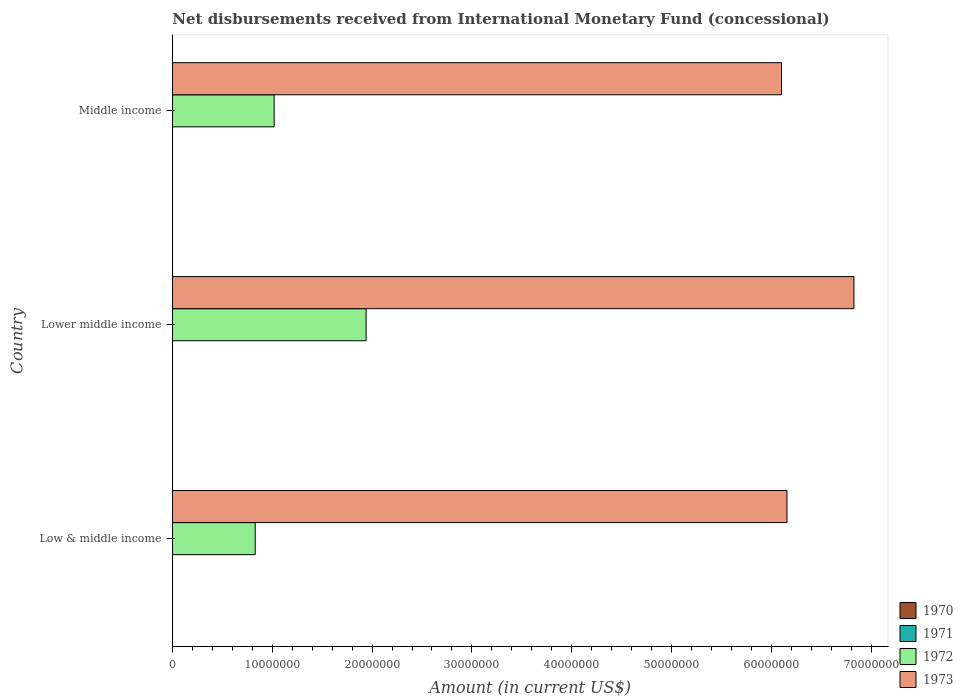How many groups of bars are there?
Provide a succinct answer. 3. Are the number of bars per tick equal to the number of legend labels?
Your answer should be very brief. No. How many bars are there on the 3rd tick from the bottom?
Offer a terse response. 2. What is the label of the 3rd group of bars from the top?
Give a very brief answer. Low & middle income. What is the amount of disbursements received from International Monetary Fund in 1973 in Middle income?
Offer a terse response. 6.10e+07. Across all countries, what is the maximum amount of disbursements received from International Monetary Fund in 1973?
Keep it short and to the point. 6.83e+07. Across all countries, what is the minimum amount of disbursements received from International Monetary Fund in 1973?
Ensure brevity in your answer.  6.10e+07. In which country was the amount of disbursements received from International Monetary Fund in 1973 maximum?
Your answer should be compact. Lower middle income. What is the difference between the amount of disbursements received from International Monetary Fund in 1972 in Low & middle income and that in Lower middle income?
Offer a terse response. -1.11e+07. What is the difference between the amount of disbursements received from International Monetary Fund in 1970 in Lower middle income and the amount of disbursements received from International Monetary Fund in 1972 in Low & middle income?
Offer a terse response. -8.30e+06. What is the difference between the amount of disbursements received from International Monetary Fund in 1973 and amount of disbursements received from International Monetary Fund in 1972 in Lower middle income?
Your response must be concise. 4.89e+07. What is the ratio of the amount of disbursements received from International Monetary Fund in 1973 in Lower middle income to that in Middle income?
Offer a terse response. 1.12. What is the difference between the highest and the second highest amount of disbursements received from International Monetary Fund in 1973?
Give a very brief answer. 6.70e+06. What is the difference between the highest and the lowest amount of disbursements received from International Monetary Fund in 1972?
Your answer should be very brief. 1.11e+07. Is the sum of the amount of disbursements received from International Monetary Fund in 1973 in Low & middle income and Middle income greater than the maximum amount of disbursements received from International Monetary Fund in 1970 across all countries?
Offer a terse response. Yes. Is it the case that in every country, the sum of the amount of disbursements received from International Monetary Fund in 1971 and amount of disbursements received from International Monetary Fund in 1970 is greater than the sum of amount of disbursements received from International Monetary Fund in 1973 and amount of disbursements received from International Monetary Fund in 1972?
Your answer should be very brief. No. Is it the case that in every country, the sum of the amount of disbursements received from International Monetary Fund in 1970 and amount of disbursements received from International Monetary Fund in 1971 is greater than the amount of disbursements received from International Monetary Fund in 1973?
Your answer should be compact. No. How many bars are there?
Make the answer very short. 6. Are the values on the major ticks of X-axis written in scientific E-notation?
Make the answer very short. No. Does the graph contain any zero values?
Provide a short and direct response. Yes. Where does the legend appear in the graph?
Give a very brief answer. Bottom right. How many legend labels are there?
Keep it short and to the point. 4. What is the title of the graph?
Offer a very short reply. Net disbursements received from International Monetary Fund (concessional). Does "1985" appear as one of the legend labels in the graph?
Ensure brevity in your answer.  No. What is the label or title of the X-axis?
Give a very brief answer. Amount (in current US$). What is the label or title of the Y-axis?
Provide a short and direct response. Country. What is the Amount (in current US$) in 1971 in Low & middle income?
Your response must be concise. 0. What is the Amount (in current US$) of 1972 in Low & middle income?
Your answer should be compact. 8.30e+06. What is the Amount (in current US$) in 1973 in Low & middle income?
Make the answer very short. 6.16e+07. What is the Amount (in current US$) in 1972 in Lower middle income?
Offer a very short reply. 1.94e+07. What is the Amount (in current US$) of 1973 in Lower middle income?
Provide a short and direct response. 6.83e+07. What is the Amount (in current US$) in 1972 in Middle income?
Your answer should be compact. 1.02e+07. What is the Amount (in current US$) in 1973 in Middle income?
Make the answer very short. 6.10e+07. Across all countries, what is the maximum Amount (in current US$) in 1972?
Offer a terse response. 1.94e+07. Across all countries, what is the maximum Amount (in current US$) of 1973?
Provide a short and direct response. 6.83e+07. Across all countries, what is the minimum Amount (in current US$) in 1972?
Offer a terse response. 8.30e+06. Across all countries, what is the minimum Amount (in current US$) of 1973?
Your answer should be compact. 6.10e+07. What is the total Amount (in current US$) in 1970 in the graph?
Provide a short and direct response. 0. What is the total Amount (in current US$) of 1971 in the graph?
Your answer should be very brief. 0. What is the total Amount (in current US$) in 1972 in the graph?
Make the answer very short. 3.79e+07. What is the total Amount (in current US$) of 1973 in the graph?
Provide a short and direct response. 1.91e+08. What is the difference between the Amount (in current US$) of 1972 in Low & middle income and that in Lower middle income?
Provide a succinct answer. -1.11e+07. What is the difference between the Amount (in current US$) of 1973 in Low & middle income and that in Lower middle income?
Offer a terse response. -6.70e+06. What is the difference between the Amount (in current US$) in 1972 in Low & middle income and that in Middle income?
Keep it short and to the point. -1.90e+06. What is the difference between the Amount (in current US$) of 1973 in Low & middle income and that in Middle income?
Provide a succinct answer. 5.46e+05. What is the difference between the Amount (in current US$) in 1972 in Lower middle income and that in Middle income?
Provide a short and direct response. 9.21e+06. What is the difference between the Amount (in current US$) in 1973 in Lower middle income and that in Middle income?
Give a very brief answer. 7.25e+06. What is the difference between the Amount (in current US$) of 1972 in Low & middle income and the Amount (in current US$) of 1973 in Lower middle income?
Your response must be concise. -6.00e+07. What is the difference between the Amount (in current US$) of 1972 in Low & middle income and the Amount (in current US$) of 1973 in Middle income?
Keep it short and to the point. -5.27e+07. What is the difference between the Amount (in current US$) in 1972 in Lower middle income and the Amount (in current US$) in 1973 in Middle income?
Make the answer very short. -4.16e+07. What is the average Amount (in current US$) of 1970 per country?
Provide a succinct answer. 0. What is the average Amount (in current US$) in 1971 per country?
Provide a succinct answer. 0. What is the average Amount (in current US$) of 1972 per country?
Offer a very short reply. 1.26e+07. What is the average Amount (in current US$) in 1973 per country?
Your answer should be compact. 6.36e+07. What is the difference between the Amount (in current US$) of 1972 and Amount (in current US$) of 1973 in Low & middle income?
Give a very brief answer. -5.33e+07. What is the difference between the Amount (in current US$) of 1972 and Amount (in current US$) of 1973 in Lower middle income?
Your response must be concise. -4.89e+07. What is the difference between the Amount (in current US$) of 1972 and Amount (in current US$) of 1973 in Middle income?
Keep it short and to the point. -5.08e+07. What is the ratio of the Amount (in current US$) in 1972 in Low & middle income to that in Lower middle income?
Provide a short and direct response. 0.43. What is the ratio of the Amount (in current US$) in 1973 in Low & middle income to that in Lower middle income?
Your response must be concise. 0.9. What is the ratio of the Amount (in current US$) in 1972 in Low & middle income to that in Middle income?
Provide a short and direct response. 0.81. What is the ratio of the Amount (in current US$) in 1973 in Low & middle income to that in Middle income?
Provide a short and direct response. 1.01. What is the ratio of the Amount (in current US$) of 1972 in Lower middle income to that in Middle income?
Provide a succinct answer. 1.9. What is the ratio of the Amount (in current US$) of 1973 in Lower middle income to that in Middle income?
Offer a terse response. 1.12. What is the difference between the highest and the second highest Amount (in current US$) in 1972?
Offer a very short reply. 9.21e+06. What is the difference between the highest and the second highest Amount (in current US$) of 1973?
Your answer should be compact. 6.70e+06. What is the difference between the highest and the lowest Amount (in current US$) in 1972?
Your answer should be very brief. 1.11e+07. What is the difference between the highest and the lowest Amount (in current US$) of 1973?
Provide a succinct answer. 7.25e+06. 